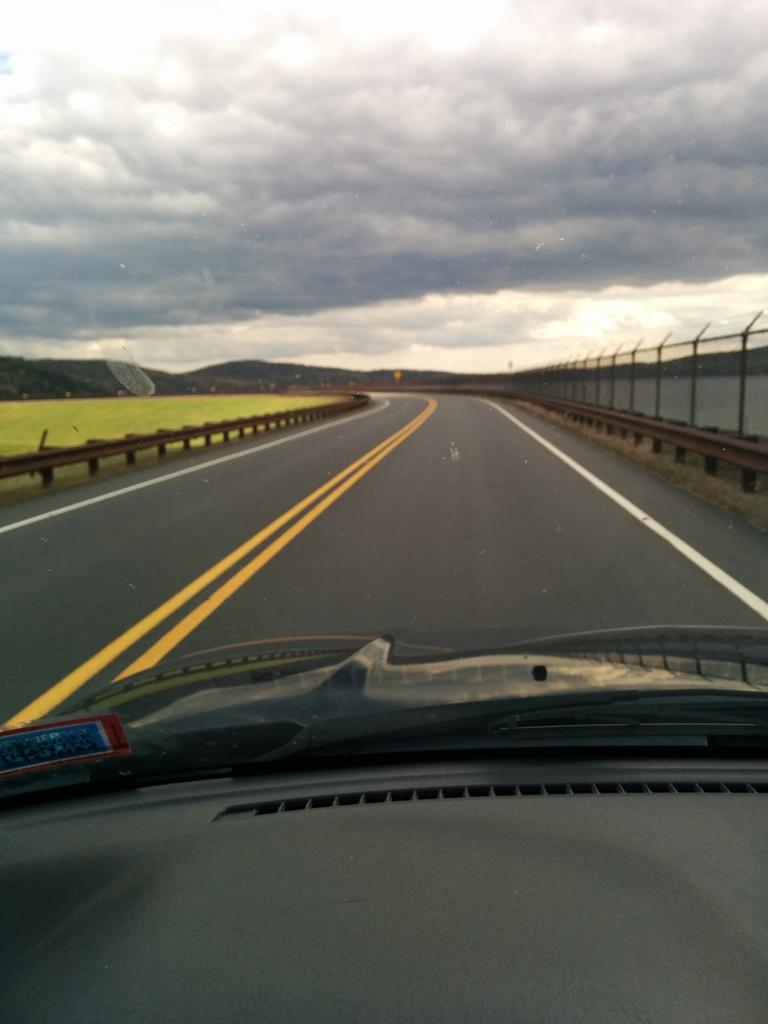What is the perspective of the image? The image is captured from inside a vehicle. What can be seen in the background of the image? There is a road, grass, hills, and the sky visible in the background. What type of tax is being discussed in the image? There is no discussion of tax in the image; it is a visual representation of a scene with a road, grass, hills, and the sky visible in the background. 